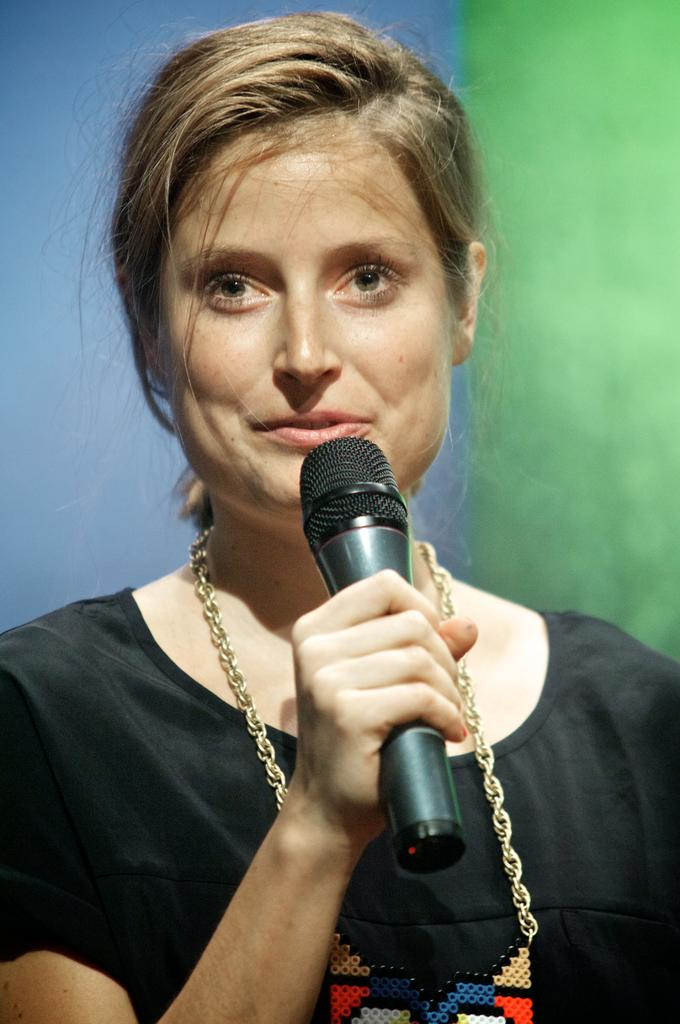What is the main subject of the image? There is a person in the image. What is the person wearing? The person is wearing a black t-shirt. What is the person holding in the image? The person is holding a microphone. Can you describe the background of the image? The background of the image is green and blue. What type of bean is being attacked by wool in the image? There is no bean or wool present in the image. 